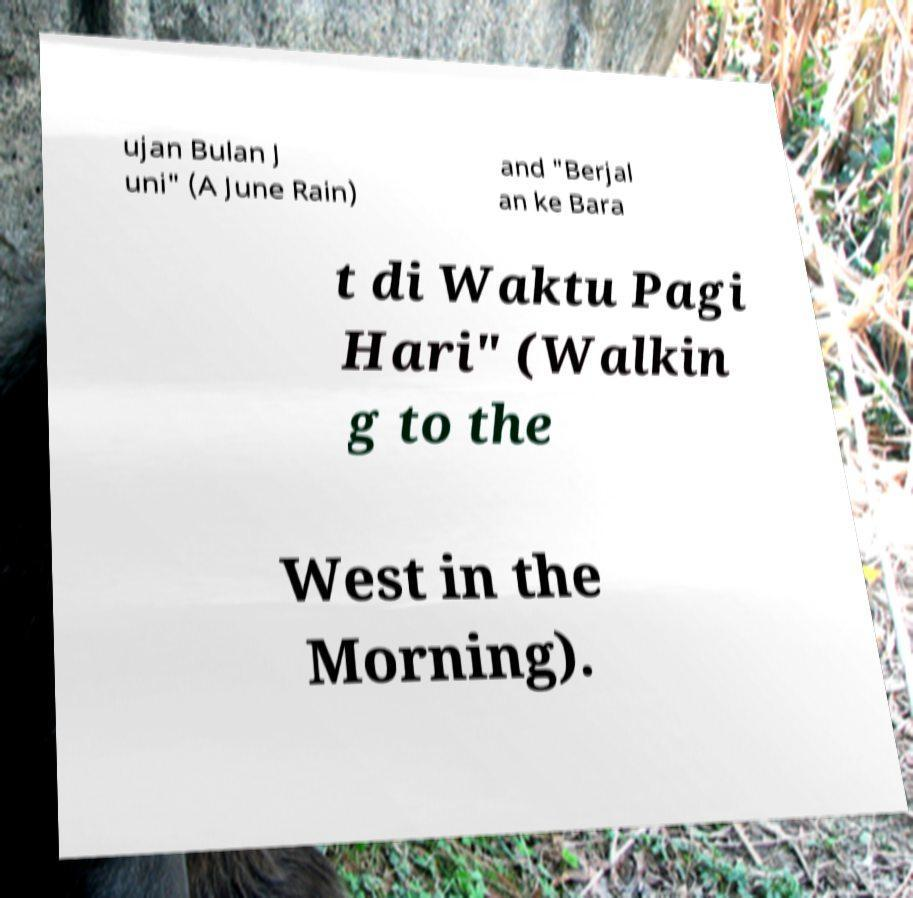Can you accurately transcribe the text from the provided image for me? ujan Bulan J uni" (A June Rain) and "Berjal an ke Bara t di Waktu Pagi Hari" (Walkin g to the West in the Morning). 